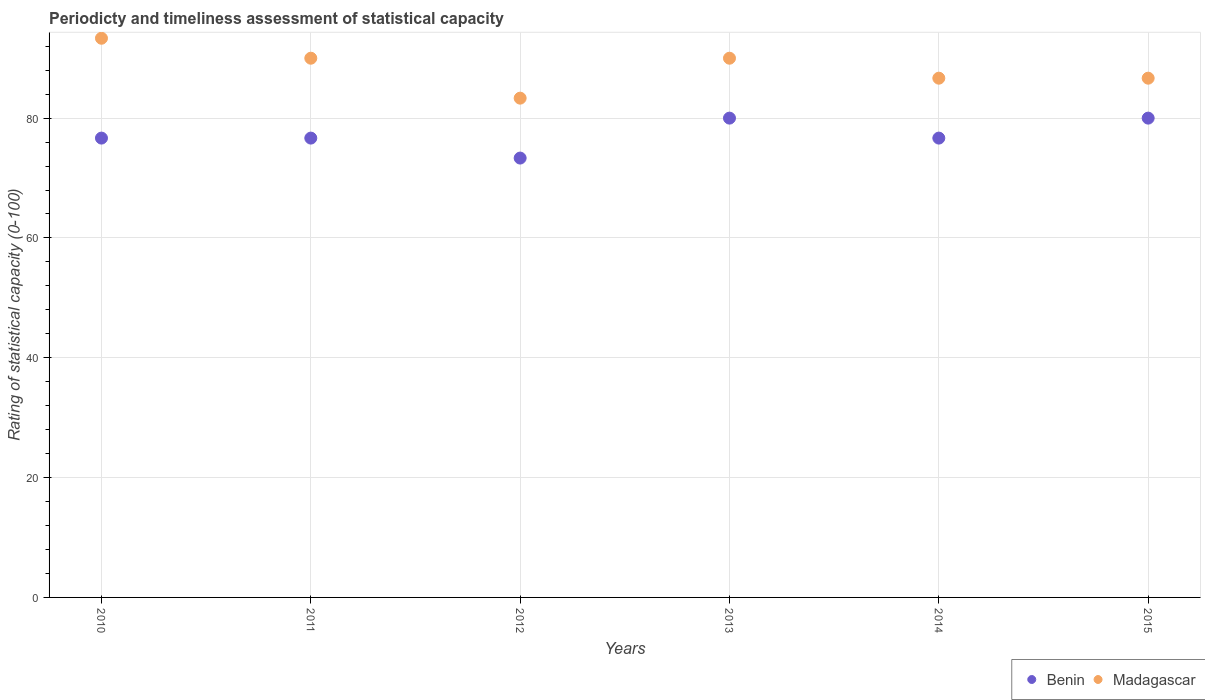What is the rating of statistical capacity in Madagascar in 2015?
Your response must be concise. 86.67. Across all years, what is the maximum rating of statistical capacity in Benin?
Give a very brief answer. 80. Across all years, what is the minimum rating of statistical capacity in Madagascar?
Your answer should be very brief. 83.33. In which year was the rating of statistical capacity in Madagascar maximum?
Offer a very short reply. 2010. In which year was the rating of statistical capacity in Benin minimum?
Offer a terse response. 2012. What is the total rating of statistical capacity in Madagascar in the graph?
Ensure brevity in your answer.  530. What is the difference between the rating of statistical capacity in Madagascar in 2012 and that in 2013?
Your answer should be very brief. -6.67. What is the difference between the rating of statistical capacity in Benin in 2011 and the rating of statistical capacity in Madagascar in 2013?
Offer a terse response. -13.33. What is the average rating of statistical capacity in Madagascar per year?
Offer a terse response. 88.33. In the year 2014, what is the difference between the rating of statistical capacity in Benin and rating of statistical capacity in Madagascar?
Give a very brief answer. -10. What is the ratio of the rating of statistical capacity in Madagascar in 2012 to that in 2015?
Your response must be concise. 0.96. Is the rating of statistical capacity in Benin in 2011 less than that in 2014?
Offer a very short reply. No. What is the difference between the highest and the second highest rating of statistical capacity in Benin?
Provide a short and direct response. 0. What is the difference between the highest and the lowest rating of statistical capacity in Benin?
Your answer should be very brief. 6.67. In how many years, is the rating of statistical capacity in Benin greater than the average rating of statistical capacity in Benin taken over all years?
Offer a terse response. 2. How many dotlines are there?
Your response must be concise. 2. How many years are there in the graph?
Give a very brief answer. 6. Are the values on the major ticks of Y-axis written in scientific E-notation?
Offer a very short reply. No. Does the graph contain any zero values?
Keep it short and to the point. No. Where does the legend appear in the graph?
Keep it short and to the point. Bottom right. How many legend labels are there?
Your answer should be very brief. 2. What is the title of the graph?
Provide a short and direct response. Periodicty and timeliness assessment of statistical capacity. What is the label or title of the Y-axis?
Provide a short and direct response. Rating of statistical capacity (0-100). What is the Rating of statistical capacity (0-100) of Benin in 2010?
Keep it short and to the point. 76.67. What is the Rating of statistical capacity (0-100) of Madagascar in 2010?
Keep it short and to the point. 93.33. What is the Rating of statistical capacity (0-100) of Benin in 2011?
Provide a short and direct response. 76.67. What is the Rating of statistical capacity (0-100) of Benin in 2012?
Ensure brevity in your answer.  73.33. What is the Rating of statistical capacity (0-100) in Madagascar in 2012?
Offer a terse response. 83.33. What is the Rating of statistical capacity (0-100) of Madagascar in 2013?
Offer a very short reply. 90. What is the Rating of statistical capacity (0-100) in Benin in 2014?
Offer a terse response. 76.67. What is the Rating of statistical capacity (0-100) of Madagascar in 2014?
Offer a very short reply. 86.67. What is the Rating of statistical capacity (0-100) in Benin in 2015?
Your response must be concise. 80. What is the Rating of statistical capacity (0-100) of Madagascar in 2015?
Make the answer very short. 86.67. Across all years, what is the maximum Rating of statistical capacity (0-100) in Madagascar?
Keep it short and to the point. 93.33. Across all years, what is the minimum Rating of statistical capacity (0-100) of Benin?
Your answer should be compact. 73.33. Across all years, what is the minimum Rating of statistical capacity (0-100) in Madagascar?
Ensure brevity in your answer.  83.33. What is the total Rating of statistical capacity (0-100) in Benin in the graph?
Give a very brief answer. 463.33. What is the total Rating of statistical capacity (0-100) in Madagascar in the graph?
Provide a short and direct response. 530. What is the difference between the Rating of statistical capacity (0-100) of Benin in 2010 and that in 2015?
Keep it short and to the point. -3.33. What is the difference between the Rating of statistical capacity (0-100) of Madagascar in 2010 and that in 2015?
Offer a very short reply. 6.67. What is the difference between the Rating of statistical capacity (0-100) in Madagascar in 2011 and that in 2012?
Offer a terse response. 6.67. What is the difference between the Rating of statistical capacity (0-100) in Benin in 2011 and that in 2013?
Provide a succinct answer. -3.33. What is the difference between the Rating of statistical capacity (0-100) in Madagascar in 2011 and that in 2014?
Make the answer very short. 3.33. What is the difference between the Rating of statistical capacity (0-100) in Benin in 2011 and that in 2015?
Give a very brief answer. -3.33. What is the difference between the Rating of statistical capacity (0-100) in Benin in 2012 and that in 2013?
Provide a short and direct response. -6.67. What is the difference between the Rating of statistical capacity (0-100) of Madagascar in 2012 and that in 2013?
Your response must be concise. -6.67. What is the difference between the Rating of statistical capacity (0-100) of Benin in 2012 and that in 2014?
Your response must be concise. -3.33. What is the difference between the Rating of statistical capacity (0-100) of Madagascar in 2012 and that in 2014?
Give a very brief answer. -3.33. What is the difference between the Rating of statistical capacity (0-100) in Benin in 2012 and that in 2015?
Your answer should be compact. -6.67. What is the difference between the Rating of statistical capacity (0-100) in Madagascar in 2012 and that in 2015?
Keep it short and to the point. -3.33. What is the difference between the Rating of statistical capacity (0-100) in Benin in 2013 and that in 2014?
Offer a terse response. 3.33. What is the difference between the Rating of statistical capacity (0-100) in Madagascar in 2013 and that in 2014?
Offer a very short reply. 3.33. What is the difference between the Rating of statistical capacity (0-100) of Benin in 2013 and that in 2015?
Your response must be concise. 0. What is the difference between the Rating of statistical capacity (0-100) in Benin in 2010 and the Rating of statistical capacity (0-100) in Madagascar in 2011?
Provide a succinct answer. -13.33. What is the difference between the Rating of statistical capacity (0-100) in Benin in 2010 and the Rating of statistical capacity (0-100) in Madagascar in 2012?
Provide a short and direct response. -6.67. What is the difference between the Rating of statistical capacity (0-100) in Benin in 2010 and the Rating of statistical capacity (0-100) in Madagascar in 2013?
Make the answer very short. -13.33. What is the difference between the Rating of statistical capacity (0-100) in Benin in 2010 and the Rating of statistical capacity (0-100) in Madagascar in 2014?
Offer a terse response. -10. What is the difference between the Rating of statistical capacity (0-100) of Benin in 2010 and the Rating of statistical capacity (0-100) of Madagascar in 2015?
Offer a very short reply. -10. What is the difference between the Rating of statistical capacity (0-100) in Benin in 2011 and the Rating of statistical capacity (0-100) in Madagascar in 2012?
Keep it short and to the point. -6.67. What is the difference between the Rating of statistical capacity (0-100) in Benin in 2011 and the Rating of statistical capacity (0-100) in Madagascar in 2013?
Your answer should be very brief. -13.33. What is the difference between the Rating of statistical capacity (0-100) of Benin in 2011 and the Rating of statistical capacity (0-100) of Madagascar in 2014?
Keep it short and to the point. -10. What is the difference between the Rating of statistical capacity (0-100) of Benin in 2012 and the Rating of statistical capacity (0-100) of Madagascar in 2013?
Your response must be concise. -16.67. What is the difference between the Rating of statistical capacity (0-100) of Benin in 2012 and the Rating of statistical capacity (0-100) of Madagascar in 2014?
Make the answer very short. -13.33. What is the difference between the Rating of statistical capacity (0-100) of Benin in 2012 and the Rating of statistical capacity (0-100) of Madagascar in 2015?
Make the answer very short. -13.33. What is the difference between the Rating of statistical capacity (0-100) in Benin in 2013 and the Rating of statistical capacity (0-100) in Madagascar in 2014?
Provide a succinct answer. -6.67. What is the difference between the Rating of statistical capacity (0-100) in Benin in 2013 and the Rating of statistical capacity (0-100) in Madagascar in 2015?
Your response must be concise. -6.67. What is the difference between the Rating of statistical capacity (0-100) in Benin in 2014 and the Rating of statistical capacity (0-100) in Madagascar in 2015?
Your answer should be compact. -10. What is the average Rating of statistical capacity (0-100) of Benin per year?
Make the answer very short. 77.22. What is the average Rating of statistical capacity (0-100) of Madagascar per year?
Your answer should be compact. 88.33. In the year 2010, what is the difference between the Rating of statistical capacity (0-100) in Benin and Rating of statistical capacity (0-100) in Madagascar?
Make the answer very short. -16.67. In the year 2011, what is the difference between the Rating of statistical capacity (0-100) in Benin and Rating of statistical capacity (0-100) in Madagascar?
Give a very brief answer. -13.33. In the year 2014, what is the difference between the Rating of statistical capacity (0-100) in Benin and Rating of statistical capacity (0-100) in Madagascar?
Your answer should be compact. -10. In the year 2015, what is the difference between the Rating of statistical capacity (0-100) in Benin and Rating of statistical capacity (0-100) in Madagascar?
Give a very brief answer. -6.67. What is the ratio of the Rating of statistical capacity (0-100) in Benin in 2010 to that in 2011?
Offer a very short reply. 1. What is the ratio of the Rating of statistical capacity (0-100) in Madagascar in 2010 to that in 2011?
Make the answer very short. 1.04. What is the ratio of the Rating of statistical capacity (0-100) of Benin in 2010 to that in 2012?
Give a very brief answer. 1.05. What is the ratio of the Rating of statistical capacity (0-100) of Madagascar in 2010 to that in 2012?
Your answer should be very brief. 1.12. What is the ratio of the Rating of statistical capacity (0-100) in Benin in 2010 to that in 2014?
Keep it short and to the point. 1. What is the ratio of the Rating of statistical capacity (0-100) in Madagascar in 2010 to that in 2014?
Provide a succinct answer. 1.08. What is the ratio of the Rating of statistical capacity (0-100) of Madagascar in 2010 to that in 2015?
Provide a short and direct response. 1.08. What is the ratio of the Rating of statistical capacity (0-100) of Benin in 2011 to that in 2012?
Offer a very short reply. 1.05. What is the ratio of the Rating of statistical capacity (0-100) in Benin in 2011 to that in 2013?
Ensure brevity in your answer.  0.96. What is the ratio of the Rating of statistical capacity (0-100) in Madagascar in 2011 to that in 2013?
Your response must be concise. 1. What is the ratio of the Rating of statistical capacity (0-100) in Benin in 2011 to that in 2014?
Offer a very short reply. 1. What is the ratio of the Rating of statistical capacity (0-100) of Madagascar in 2011 to that in 2014?
Ensure brevity in your answer.  1.04. What is the ratio of the Rating of statistical capacity (0-100) of Benin in 2011 to that in 2015?
Ensure brevity in your answer.  0.96. What is the ratio of the Rating of statistical capacity (0-100) in Madagascar in 2011 to that in 2015?
Provide a short and direct response. 1.04. What is the ratio of the Rating of statistical capacity (0-100) in Madagascar in 2012 to that in 2013?
Your response must be concise. 0.93. What is the ratio of the Rating of statistical capacity (0-100) in Benin in 2012 to that in 2014?
Your answer should be compact. 0.96. What is the ratio of the Rating of statistical capacity (0-100) in Madagascar in 2012 to that in 2014?
Your answer should be compact. 0.96. What is the ratio of the Rating of statistical capacity (0-100) of Madagascar in 2012 to that in 2015?
Keep it short and to the point. 0.96. What is the ratio of the Rating of statistical capacity (0-100) of Benin in 2013 to that in 2014?
Give a very brief answer. 1.04. What is the ratio of the Rating of statistical capacity (0-100) in Madagascar in 2013 to that in 2015?
Your response must be concise. 1.04. What is the ratio of the Rating of statistical capacity (0-100) of Benin in 2014 to that in 2015?
Your answer should be compact. 0.96. What is the difference between the highest and the lowest Rating of statistical capacity (0-100) in Benin?
Make the answer very short. 6.67. What is the difference between the highest and the lowest Rating of statistical capacity (0-100) in Madagascar?
Offer a terse response. 10. 